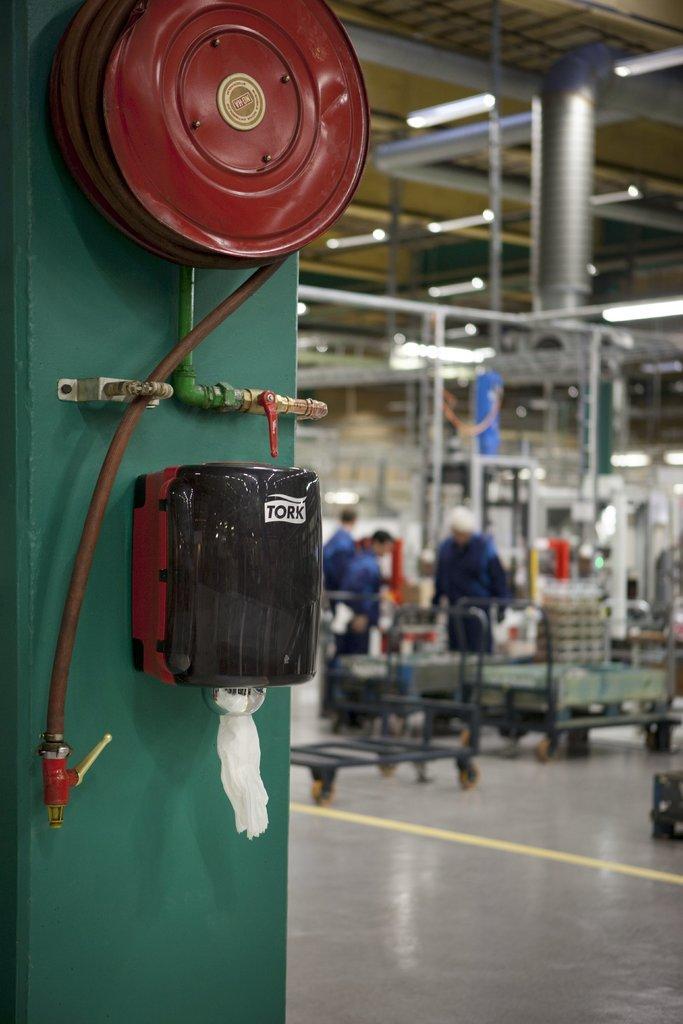Describe this image in one or two sentences. In this image we can see a wall, pipes and other objects on the left side of the image. In the background of the image there are persons, iron objects and other objects. At the bottom of the image there is the floor. At the top of the image there is the ceiling and iron objects. 